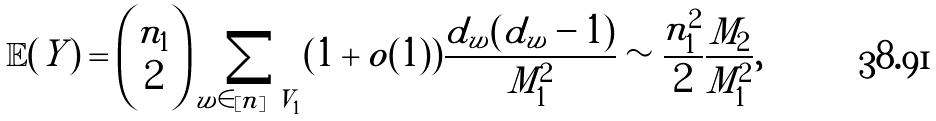Convert formula to latex. <formula><loc_0><loc_0><loc_500><loc_500>\mathbb { E } ( Y ) & = { n _ { 1 } \choose 2 } \sum _ { w \in [ n ] \ V _ { 1 } } ( 1 + o ( 1 ) ) \frac { d _ { w } ( d _ { w } - 1 ) } { M _ { 1 } ^ { 2 } } \sim \frac { n _ { 1 } ^ { 2 } } { 2 } \frac { M _ { 2 } } { M _ { 1 } ^ { 2 } } ,</formula> 